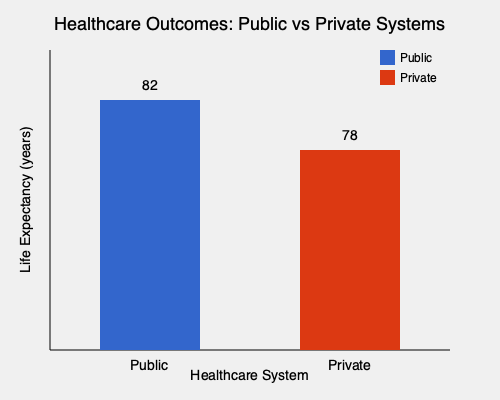Based on the chart comparing public and private healthcare systems, what is the difference in life expectancy between the two systems, and how might this data support arguments for public healthcare reform? To answer this question, we need to follow these steps:

1. Identify the life expectancy values:
   - Public healthcare system: 82 years
   - Private healthcare system: 78 years

2. Calculate the difference:
   $82 - 78 = 4$ years

3. Interpret the results in the context of public healthcare reform:
   - The public healthcare system shows a 4-year higher life expectancy.
   - This significant difference suggests that public healthcare systems may be more effective in improving overall population health outcomes.
   - As a government official opposing insurance company influence, this data could be used to argue that:
     a) Public systems prioritize health outcomes over profit motives.
     b) Government-run healthcare can potentially lead to better long-term health for citizens.
     c) Reducing private insurance influence might align healthcare goals more closely with public health needs.
     d) The data supports investing in and expanding public healthcare options rather than relying on private insurance-driven systems.

4. Consider potential policy implications:
   - Advocate for increased funding and support for public healthcare programs.
   - Propose legislation to limit insurance company lobbying in healthcare policy decisions.
   - Suggest reforms that transition more healthcare services to public management.
   - Use this data to counter arguments favoring privatization of healthcare services.
Answer: 4 years higher life expectancy in public systems; supports arguments for expanding public healthcare and limiting insurance company influence. 